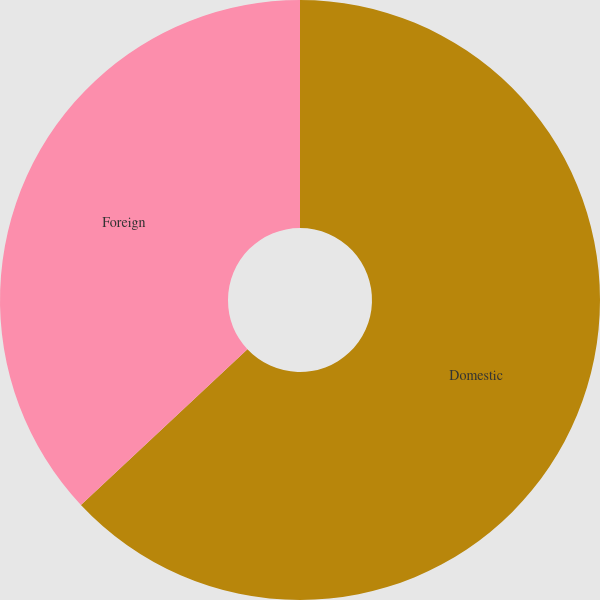Convert chart to OTSL. <chart><loc_0><loc_0><loc_500><loc_500><pie_chart><fcel>Domestic<fcel>Foreign<nl><fcel>63.03%<fcel>36.97%<nl></chart> 